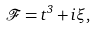Convert formula to latex. <formula><loc_0><loc_0><loc_500><loc_500>\mathcal { F } = t ^ { 3 } + i \xi ,</formula> 